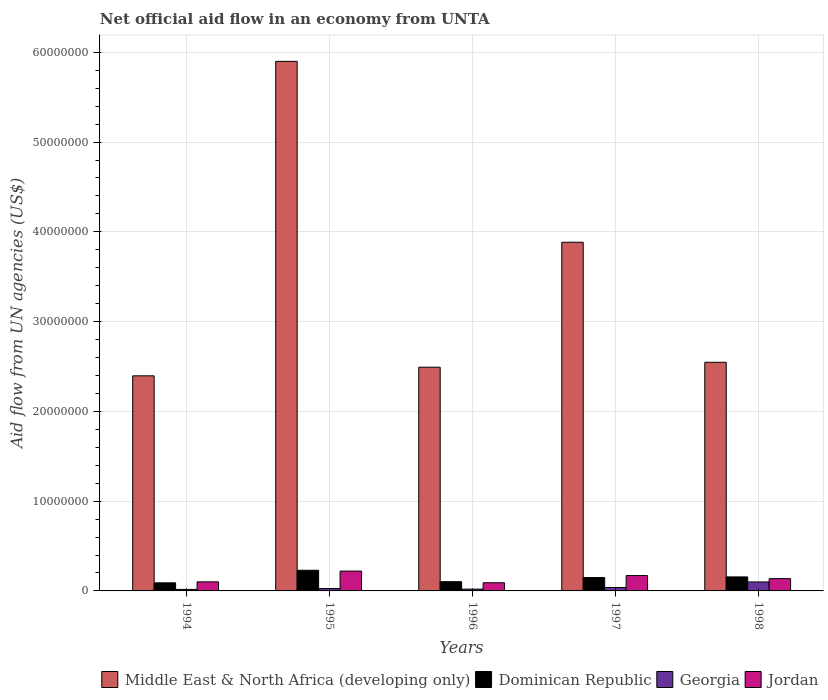How many different coloured bars are there?
Offer a very short reply. 4. How many groups of bars are there?
Your answer should be very brief. 5. Are the number of bars on each tick of the X-axis equal?
Offer a very short reply. Yes. How many bars are there on the 1st tick from the left?
Provide a succinct answer. 4. How many bars are there on the 3rd tick from the right?
Offer a terse response. 4. What is the label of the 3rd group of bars from the left?
Keep it short and to the point. 1996. In how many cases, is the number of bars for a given year not equal to the number of legend labels?
Give a very brief answer. 0. What is the net official aid flow in Dominican Republic in 1996?
Keep it short and to the point. 1.03e+06. Across all years, what is the maximum net official aid flow in Dominican Republic?
Offer a terse response. 2.30e+06. Across all years, what is the minimum net official aid flow in Jordan?
Your answer should be very brief. 9.10e+05. In which year was the net official aid flow in Jordan minimum?
Ensure brevity in your answer.  1996. What is the total net official aid flow in Dominican Republic in the graph?
Offer a terse response. 7.28e+06. What is the difference between the net official aid flow in Georgia in 1998 and the net official aid flow in Jordan in 1995?
Ensure brevity in your answer.  -1.21e+06. What is the average net official aid flow in Dominican Republic per year?
Offer a very short reply. 1.46e+06. In the year 1994, what is the difference between the net official aid flow in Jordan and net official aid flow in Georgia?
Ensure brevity in your answer.  8.40e+05. In how many years, is the net official aid flow in Middle East & North Africa (developing only) greater than 56000000 US$?
Keep it short and to the point. 1. What is the ratio of the net official aid flow in Jordan in 1995 to that in 1997?
Provide a succinct answer. 1.29. Is the net official aid flow in Dominican Republic in 1995 less than that in 1998?
Make the answer very short. No. What is the difference between the highest and the second highest net official aid flow in Dominican Republic?
Offer a terse response. 7.40e+05. What is the difference between the highest and the lowest net official aid flow in Middle East & North Africa (developing only)?
Make the answer very short. 3.50e+07. Is the sum of the net official aid flow in Dominican Republic in 1996 and 1997 greater than the maximum net official aid flow in Middle East & North Africa (developing only) across all years?
Your response must be concise. No. Is it the case that in every year, the sum of the net official aid flow in Jordan and net official aid flow in Middle East & North Africa (developing only) is greater than the sum of net official aid flow in Dominican Republic and net official aid flow in Georgia?
Make the answer very short. Yes. What does the 3rd bar from the left in 1994 represents?
Your answer should be compact. Georgia. What does the 4th bar from the right in 1996 represents?
Make the answer very short. Middle East & North Africa (developing only). Is it the case that in every year, the sum of the net official aid flow in Georgia and net official aid flow in Jordan is greater than the net official aid flow in Dominican Republic?
Give a very brief answer. Yes. Are all the bars in the graph horizontal?
Your answer should be compact. No. What is the difference between two consecutive major ticks on the Y-axis?
Provide a succinct answer. 1.00e+07. How many legend labels are there?
Your answer should be very brief. 4. What is the title of the graph?
Provide a succinct answer. Net official aid flow in an economy from UNTA. What is the label or title of the Y-axis?
Offer a terse response. Aid flow from UN agencies (US$). What is the Aid flow from UN agencies (US$) in Middle East & North Africa (developing only) in 1994?
Provide a succinct answer. 2.40e+07. What is the Aid flow from UN agencies (US$) of Dominican Republic in 1994?
Ensure brevity in your answer.  9.00e+05. What is the Aid flow from UN agencies (US$) in Jordan in 1994?
Your answer should be very brief. 1.01e+06. What is the Aid flow from UN agencies (US$) in Middle East & North Africa (developing only) in 1995?
Provide a succinct answer. 5.90e+07. What is the Aid flow from UN agencies (US$) of Dominican Republic in 1995?
Your answer should be compact. 2.30e+06. What is the Aid flow from UN agencies (US$) of Jordan in 1995?
Your response must be concise. 2.21e+06. What is the Aid flow from UN agencies (US$) of Middle East & North Africa (developing only) in 1996?
Make the answer very short. 2.49e+07. What is the Aid flow from UN agencies (US$) of Dominican Republic in 1996?
Keep it short and to the point. 1.03e+06. What is the Aid flow from UN agencies (US$) of Georgia in 1996?
Provide a succinct answer. 2.00e+05. What is the Aid flow from UN agencies (US$) of Jordan in 1996?
Your answer should be compact. 9.10e+05. What is the Aid flow from UN agencies (US$) of Middle East & North Africa (developing only) in 1997?
Make the answer very short. 3.88e+07. What is the Aid flow from UN agencies (US$) in Dominican Republic in 1997?
Your response must be concise. 1.49e+06. What is the Aid flow from UN agencies (US$) in Georgia in 1997?
Provide a short and direct response. 3.80e+05. What is the Aid flow from UN agencies (US$) in Jordan in 1997?
Give a very brief answer. 1.71e+06. What is the Aid flow from UN agencies (US$) of Middle East & North Africa (developing only) in 1998?
Provide a succinct answer. 2.55e+07. What is the Aid flow from UN agencies (US$) in Dominican Republic in 1998?
Offer a terse response. 1.56e+06. What is the Aid flow from UN agencies (US$) in Jordan in 1998?
Your response must be concise. 1.37e+06. Across all years, what is the maximum Aid flow from UN agencies (US$) in Middle East & North Africa (developing only)?
Your response must be concise. 5.90e+07. Across all years, what is the maximum Aid flow from UN agencies (US$) of Dominican Republic?
Provide a short and direct response. 2.30e+06. Across all years, what is the maximum Aid flow from UN agencies (US$) of Jordan?
Your answer should be very brief. 2.21e+06. Across all years, what is the minimum Aid flow from UN agencies (US$) in Middle East & North Africa (developing only)?
Make the answer very short. 2.40e+07. Across all years, what is the minimum Aid flow from UN agencies (US$) in Dominican Republic?
Offer a terse response. 9.00e+05. Across all years, what is the minimum Aid flow from UN agencies (US$) of Georgia?
Your response must be concise. 1.70e+05. Across all years, what is the minimum Aid flow from UN agencies (US$) in Jordan?
Provide a short and direct response. 9.10e+05. What is the total Aid flow from UN agencies (US$) of Middle East & North Africa (developing only) in the graph?
Keep it short and to the point. 1.72e+08. What is the total Aid flow from UN agencies (US$) in Dominican Republic in the graph?
Your response must be concise. 7.28e+06. What is the total Aid flow from UN agencies (US$) of Georgia in the graph?
Provide a short and direct response. 2.02e+06. What is the total Aid flow from UN agencies (US$) in Jordan in the graph?
Keep it short and to the point. 7.21e+06. What is the difference between the Aid flow from UN agencies (US$) of Middle East & North Africa (developing only) in 1994 and that in 1995?
Make the answer very short. -3.50e+07. What is the difference between the Aid flow from UN agencies (US$) of Dominican Republic in 1994 and that in 1995?
Your response must be concise. -1.40e+06. What is the difference between the Aid flow from UN agencies (US$) of Jordan in 1994 and that in 1995?
Offer a very short reply. -1.20e+06. What is the difference between the Aid flow from UN agencies (US$) in Middle East & North Africa (developing only) in 1994 and that in 1996?
Offer a very short reply. -9.60e+05. What is the difference between the Aid flow from UN agencies (US$) in Dominican Republic in 1994 and that in 1996?
Keep it short and to the point. -1.30e+05. What is the difference between the Aid flow from UN agencies (US$) of Georgia in 1994 and that in 1996?
Make the answer very short. -3.00e+04. What is the difference between the Aid flow from UN agencies (US$) of Jordan in 1994 and that in 1996?
Your response must be concise. 1.00e+05. What is the difference between the Aid flow from UN agencies (US$) of Middle East & North Africa (developing only) in 1994 and that in 1997?
Your answer should be compact. -1.49e+07. What is the difference between the Aid flow from UN agencies (US$) in Dominican Republic in 1994 and that in 1997?
Your response must be concise. -5.90e+05. What is the difference between the Aid flow from UN agencies (US$) of Georgia in 1994 and that in 1997?
Your answer should be compact. -2.10e+05. What is the difference between the Aid flow from UN agencies (US$) in Jordan in 1994 and that in 1997?
Give a very brief answer. -7.00e+05. What is the difference between the Aid flow from UN agencies (US$) in Middle East & North Africa (developing only) in 1994 and that in 1998?
Provide a succinct answer. -1.51e+06. What is the difference between the Aid flow from UN agencies (US$) in Dominican Republic in 1994 and that in 1998?
Give a very brief answer. -6.60e+05. What is the difference between the Aid flow from UN agencies (US$) of Georgia in 1994 and that in 1998?
Ensure brevity in your answer.  -8.30e+05. What is the difference between the Aid flow from UN agencies (US$) in Jordan in 1994 and that in 1998?
Give a very brief answer. -3.60e+05. What is the difference between the Aid flow from UN agencies (US$) of Middle East & North Africa (developing only) in 1995 and that in 1996?
Make the answer very short. 3.41e+07. What is the difference between the Aid flow from UN agencies (US$) in Dominican Republic in 1995 and that in 1996?
Provide a short and direct response. 1.27e+06. What is the difference between the Aid flow from UN agencies (US$) of Georgia in 1995 and that in 1996?
Your response must be concise. 7.00e+04. What is the difference between the Aid flow from UN agencies (US$) of Jordan in 1995 and that in 1996?
Offer a very short reply. 1.30e+06. What is the difference between the Aid flow from UN agencies (US$) in Middle East & North Africa (developing only) in 1995 and that in 1997?
Give a very brief answer. 2.02e+07. What is the difference between the Aid flow from UN agencies (US$) in Dominican Republic in 1995 and that in 1997?
Provide a short and direct response. 8.10e+05. What is the difference between the Aid flow from UN agencies (US$) of Middle East & North Africa (developing only) in 1995 and that in 1998?
Your response must be concise. 3.35e+07. What is the difference between the Aid flow from UN agencies (US$) in Dominican Republic in 1995 and that in 1998?
Provide a short and direct response. 7.40e+05. What is the difference between the Aid flow from UN agencies (US$) in Georgia in 1995 and that in 1998?
Provide a succinct answer. -7.30e+05. What is the difference between the Aid flow from UN agencies (US$) of Jordan in 1995 and that in 1998?
Provide a short and direct response. 8.40e+05. What is the difference between the Aid flow from UN agencies (US$) of Middle East & North Africa (developing only) in 1996 and that in 1997?
Make the answer very short. -1.39e+07. What is the difference between the Aid flow from UN agencies (US$) of Dominican Republic in 1996 and that in 1997?
Your answer should be compact. -4.60e+05. What is the difference between the Aid flow from UN agencies (US$) in Georgia in 1996 and that in 1997?
Your response must be concise. -1.80e+05. What is the difference between the Aid flow from UN agencies (US$) in Jordan in 1996 and that in 1997?
Make the answer very short. -8.00e+05. What is the difference between the Aid flow from UN agencies (US$) of Middle East & North Africa (developing only) in 1996 and that in 1998?
Offer a terse response. -5.50e+05. What is the difference between the Aid flow from UN agencies (US$) of Dominican Republic in 1996 and that in 1998?
Ensure brevity in your answer.  -5.30e+05. What is the difference between the Aid flow from UN agencies (US$) in Georgia in 1996 and that in 1998?
Offer a terse response. -8.00e+05. What is the difference between the Aid flow from UN agencies (US$) of Jordan in 1996 and that in 1998?
Offer a terse response. -4.60e+05. What is the difference between the Aid flow from UN agencies (US$) of Middle East & North Africa (developing only) in 1997 and that in 1998?
Keep it short and to the point. 1.34e+07. What is the difference between the Aid flow from UN agencies (US$) of Georgia in 1997 and that in 1998?
Your answer should be very brief. -6.20e+05. What is the difference between the Aid flow from UN agencies (US$) in Middle East & North Africa (developing only) in 1994 and the Aid flow from UN agencies (US$) in Dominican Republic in 1995?
Give a very brief answer. 2.17e+07. What is the difference between the Aid flow from UN agencies (US$) in Middle East & North Africa (developing only) in 1994 and the Aid flow from UN agencies (US$) in Georgia in 1995?
Ensure brevity in your answer.  2.37e+07. What is the difference between the Aid flow from UN agencies (US$) in Middle East & North Africa (developing only) in 1994 and the Aid flow from UN agencies (US$) in Jordan in 1995?
Provide a succinct answer. 2.18e+07. What is the difference between the Aid flow from UN agencies (US$) in Dominican Republic in 1994 and the Aid flow from UN agencies (US$) in Georgia in 1995?
Keep it short and to the point. 6.30e+05. What is the difference between the Aid flow from UN agencies (US$) in Dominican Republic in 1994 and the Aid flow from UN agencies (US$) in Jordan in 1995?
Your answer should be compact. -1.31e+06. What is the difference between the Aid flow from UN agencies (US$) in Georgia in 1994 and the Aid flow from UN agencies (US$) in Jordan in 1995?
Your answer should be compact. -2.04e+06. What is the difference between the Aid flow from UN agencies (US$) in Middle East & North Africa (developing only) in 1994 and the Aid flow from UN agencies (US$) in Dominican Republic in 1996?
Your answer should be very brief. 2.29e+07. What is the difference between the Aid flow from UN agencies (US$) of Middle East & North Africa (developing only) in 1994 and the Aid flow from UN agencies (US$) of Georgia in 1996?
Ensure brevity in your answer.  2.38e+07. What is the difference between the Aid flow from UN agencies (US$) of Middle East & North Africa (developing only) in 1994 and the Aid flow from UN agencies (US$) of Jordan in 1996?
Provide a succinct answer. 2.30e+07. What is the difference between the Aid flow from UN agencies (US$) of Dominican Republic in 1994 and the Aid flow from UN agencies (US$) of Georgia in 1996?
Offer a terse response. 7.00e+05. What is the difference between the Aid flow from UN agencies (US$) of Georgia in 1994 and the Aid flow from UN agencies (US$) of Jordan in 1996?
Ensure brevity in your answer.  -7.40e+05. What is the difference between the Aid flow from UN agencies (US$) in Middle East & North Africa (developing only) in 1994 and the Aid flow from UN agencies (US$) in Dominican Republic in 1997?
Your answer should be compact. 2.25e+07. What is the difference between the Aid flow from UN agencies (US$) in Middle East & North Africa (developing only) in 1994 and the Aid flow from UN agencies (US$) in Georgia in 1997?
Offer a very short reply. 2.36e+07. What is the difference between the Aid flow from UN agencies (US$) in Middle East & North Africa (developing only) in 1994 and the Aid flow from UN agencies (US$) in Jordan in 1997?
Offer a terse response. 2.22e+07. What is the difference between the Aid flow from UN agencies (US$) of Dominican Republic in 1994 and the Aid flow from UN agencies (US$) of Georgia in 1997?
Your answer should be very brief. 5.20e+05. What is the difference between the Aid flow from UN agencies (US$) of Dominican Republic in 1994 and the Aid flow from UN agencies (US$) of Jordan in 1997?
Provide a succinct answer. -8.10e+05. What is the difference between the Aid flow from UN agencies (US$) in Georgia in 1994 and the Aid flow from UN agencies (US$) in Jordan in 1997?
Offer a very short reply. -1.54e+06. What is the difference between the Aid flow from UN agencies (US$) in Middle East & North Africa (developing only) in 1994 and the Aid flow from UN agencies (US$) in Dominican Republic in 1998?
Give a very brief answer. 2.24e+07. What is the difference between the Aid flow from UN agencies (US$) in Middle East & North Africa (developing only) in 1994 and the Aid flow from UN agencies (US$) in Georgia in 1998?
Your answer should be compact. 2.30e+07. What is the difference between the Aid flow from UN agencies (US$) in Middle East & North Africa (developing only) in 1994 and the Aid flow from UN agencies (US$) in Jordan in 1998?
Keep it short and to the point. 2.26e+07. What is the difference between the Aid flow from UN agencies (US$) in Dominican Republic in 1994 and the Aid flow from UN agencies (US$) in Georgia in 1998?
Give a very brief answer. -1.00e+05. What is the difference between the Aid flow from UN agencies (US$) in Dominican Republic in 1994 and the Aid flow from UN agencies (US$) in Jordan in 1998?
Your answer should be very brief. -4.70e+05. What is the difference between the Aid flow from UN agencies (US$) of Georgia in 1994 and the Aid flow from UN agencies (US$) of Jordan in 1998?
Your response must be concise. -1.20e+06. What is the difference between the Aid flow from UN agencies (US$) in Middle East & North Africa (developing only) in 1995 and the Aid flow from UN agencies (US$) in Dominican Republic in 1996?
Offer a very short reply. 5.80e+07. What is the difference between the Aid flow from UN agencies (US$) in Middle East & North Africa (developing only) in 1995 and the Aid flow from UN agencies (US$) in Georgia in 1996?
Give a very brief answer. 5.88e+07. What is the difference between the Aid flow from UN agencies (US$) in Middle East & North Africa (developing only) in 1995 and the Aid flow from UN agencies (US$) in Jordan in 1996?
Offer a very short reply. 5.81e+07. What is the difference between the Aid flow from UN agencies (US$) in Dominican Republic in 1995 and the Aid flow from UN agencies (US$) in Georgia in 1996?
Give a very brief answer. 2.10e+06. What is the difference between the Aid flow from UN agencies (US$) of Dominican Republic in 1995 and the Aid flow from UN agencies (US$) of Jordan in 1996?
Your answer should be very brief. 1.39e+06. What is the difference between the Aid flow from UN agencies (US$) in Georgia in 1995 and the Aid flow from UN agencies (US$) in Jordan in 1996?
Make the answer very short. -6.40e+05. What is the difference between the Aid flow from UN agencies (US$) in Middle East & North Africa (developing only) in 1995 and the Aid flow from UN agencies (US$) in Dominican Republic in 1997?
Offer a very short reply. 5.75e+07. What is the difference between the Aid flow from UN agencies (US$) of Middle East & North Africa (developing only) in 1995 and the Aid flow from UN agencies (US$) of Georgia in 1997?
Your response must be concise. 5.86e+07. What is the difference between the Aid flow from UN agencies (US$) in Middle East & North Africa (developing only) in 1995 and the Aid flow from UN agencies (US$) in Jordan in 1997?
Ensure brevity in your answer.  5.73e+07. What is the difference between the Aid flow from UN agencies (US$) of Dominican Republic in 1995 and the Aid flow from UN agencies (US$) of Georgia in 1997?
Ensure brevity in your answer.  1.92e+06. What is the difference between the Aid flow from UN agencies (US$) of Dominican Republic in 1995 and the Aid flow from UN agencies (US$) of Jordan in 1997?
Give a very brief answer. 5.90e+05. What is the difference between the Aid flow from UN agencies (US$) in Georgia in 1995 and the Aid flow from UN agencies (US$) in Jordan in 1997?
Your response must be concise. -1.44e+06. What is the difference between the Aid flow from UN agencies (US$) in Middle East & North Africa (developing only) in 1995 and the Aid flow from UN agencies (US$) in Dominican Republic in 1998?
Your answer should be compact. 5.74e+07. What is the difference between the Aid flow from UN agencies (US$) in Middle East & North Africa (developing only) in 1995 and the Aid flow from UN agencies (US$) in Georgia in 1998?
Provide a short and direct response. 5.80e+07. What is the difference between the Aid flow from UN agencies (US$) of Middle East & North Africa (developing only) in 1995 and the Aid flow from UN agencies (US$) of Jordan in 1998?
Ensure brevity in your answer.  5.76e+07. What is the difference between the Aid flow from UN agencies (US$) of Dominican Republic in 1995 and the Aid flow from UN agencies (US$) of Georgia in 1998?
Your answer should be compact. 1.30e+06. What is the difference between the Aid flow from UN agencies (US$) of Dominican Republic in 1995 and the Aid flow from UN agencies (US$) of Jordan in 1998?
Your answer should be compact. 9.30e+05. What is the difference between the Aid flow from UN agencies (US$) of Georgia in 1995 and the Aid flow from UN agencies (US$) of Jordan in 1998?
Provide a short and direct response. -1.10e+06. What is the difference between the Aid flow from UN agencies (US$) of Middle East & North Africa (developing only) in 1996 and the Aid flow from UN agencies (US$) of Dominican Republic in 1997?
Provide a succinct answer. 2.34e+07. What is the difference between the Aid flow from UN agencies (US$) of Middle East & North Africa (developing only) in 1996 and the Aid flow from UN agencies (US$) of Georgia in 1997?
Give a very brief answer. 2.45e+07. What is the difference between the Aid flow from UN agencies (US$) in Middle East & North Africa (developing only) in 1996 and the Aid flow from UN agencies (US$) in Jordan in 1997?
Your response must be concise. 2.32e+07. What is the difference between the Aid flow from UN agencies (US$) in Dominican Republic in 1996 and the Aid flow from UN agencies (US$) in Georgia in 1997?
Offer a terse response. 6.50e+05. What is the difference between the Aid flow from UN agencies (US$) of Dominican Republic in 1996 and the Aid flow from UN agencies (US$) of Jordan in 1997?
Provide a short and direct response. -6.80e+05. What is the difference between the Aid flow from UN agencies (US$) of Georgia in 1996 and the Aid flow from UN agencies (US$) of Jordan in 1997?
Ensure brevity in your answer.  -1.51e+06. What is the difference between the Aid flow from UN agencies (US$) of Middle East & North Africa (developing only) in 1996 and the Aid flow from UN agencies (US$) of Dominican Republic in 1998?
Make the answer very short. 2.34e+07. What is the difference between the Aid flow from UN agencies (US$) in Middle East & North Africa (developing only) in 1996 and the Aid flow from UN agencies (US$) in Georgia in 1998?
Your answer should be compact. 2.39e+07. What is the difference between the Aid flow from UN agencies (US$) in Middle East & North Africa (developing only) in 1996 and the Aid flow from UN agencies (US$) in Jordan in 1998?
Ensure brevity in your answer.  2.36e+07. What is the difference between the Aid flow from UN agencies (US$) in Dominican Republic in 1996 and the Aid flow from UN agencies (US$) in Georgia in 1998?
Ensure brevity in your answer.  3.00e+04. What is the difference between the Aid flow from UN agencies (US$) of Dominican Republic in 1996 and the Aid flow from UN agencies (US$) of Jordan in 1998?
Your answer should be compact. -3.40e+05. What is the difference between the Aid flow from UN agencies (US$) in Georgia in 1996 and the Aid flow from UN agencies (US$) in Jordan in 1998?
Your answer should be very brief. -1.17e+06. What is the difference between the Aid flow from UN agencies (US$) in Middle East & North Africa (developing only) in 1997 and the Aid flow from UN agencies (US$) in Dominican Republic in 1998?
Offer a very short reply. 3.73e+07. What is the difference between the Aid flow from UN agencies (US$) in Middle East & North Africa (developing only) in 1997 and the Aid flow from UN agencies (US$) in Georgia in 1998?
Your answer should be compact. 3.78e+07. What is the difference between the Aid flow from UN agencies (US$) in Middle East & North Africa (developing only) in 1997 and the Aid flow from UN agencies (US$) in Jordan in 1998?
Make the answer very short. 3.75e+07. What is the difference between the Aid flow from UN agencies (US$) of Dominican Republic in 1997 and the Aid flow from UN agencies (US$) of Georgia in 1998?
Your answer should be very brief. 4.90e+05. What is the difference between the Aid flow from UN agencies (US$) in Georgia in 1997 and the Aid flow from UN agencies (US$) in Jordan in 1998?
Your answer should be compact. -9.90e+05. What is the average Aid flow from UN agencies (US$) of Middle East & North Africa (developing only) per year?
Your answer should be compact. 3.44e+07. What is the average Aid flow from UN agencies (US$) of Dominican Republic per year?
Your response must be concise. 1.46e+06. What is the average Aid flow from UN agencies (US$) of Georgia per year?
Provide a short and direct response. 4.04e+05. What is the average Aid flow from UN agencies (US$) of Jordan per year?
Give a very brief answer. 1.44e+06. In the year 1994, what is the difference between the Aid flow from UN agencies (US$) in Middle East & North Africa (developing only) and Aid flow from UN agencies (US$) in Dominican Republic?
Your answer should be compact. 2.31e+07. In the year 1994, what is the difference between the Aid flow from UN agencies (US$) of Middle East & North Africa (developing only) and Aid flow from UN agencies (US$) of Georgia?
Provide a short and direct response. 2.38e+07. In the year 1994, what is the difference between the Aid flow from UN agencies (US$) in Middle East & North Africa (developing only) and Aid flow from UN agencies (US$) in Jordan?
Offer a terse response. 2.30e+07. In the year 1994, what is the difference between the Aid flow from UN agencies (US$) of Dominican Republic and Aid flow from UN agencies (US$) of Georgia?
Provide a succinct answer. 7.30e+05. In the year 1994, what is the difference between the Aid flow from UN agencies (US$) in Dominican Republic and Aid flow from UN agencies (US$) in Jordan?
Provide a succinct answer. -1.10e+05. In the year 1994, what is the difference between the Aid flow from UN agencies (US$) in Georgia and Aid flow from UN agencies (US$) in Jordan?
Provide a short and direct response. -8.40e+05. In the year 1995, what is the difference between the Aid flow from UN agencies (US$) in Middle East & North Africa (developing only) and Aid flow from UN agencies (US$) in Dominican Republic?
Offer a very short reply. 5.67e+07. In the year 1995, what is the difference between the Aid flow from UN agencies (US$) in Middle East & North Africa (developing only) and Aid flow from UN agencies (US$) in Georgia?
Offer a terse response. 5.87e+07. In the year 1995, what is the difference between the Aid flow from UN agencies (US$) in Middle East & North Africa (developing only) and Aid flow from UN agencies (US$) in Jordan?
Make the answer very short. 5.68e+07. In the year 1995, what is the difference between the Aid flow from UN agencies (US$) of Dominican Republic and Aid flow from UN agencies (US$) of Georgia?
Provide a succinct answer. 2.03e+06. In the year 1995, what is the difference between the Aid flow from UN agencies (US$) in Georgia and Aid flow from UN agencies (US$) in Jordan?
Ensure brevity in your answer.  -1.94e+06. In the year 1996, what is the difference between the Aid flow from UN agencies (US$) in Middle East & North Africa (developing only) and Aid flow from UN agencies (US$) in Dominican Republic?
Your answer should be compact. 2.39e+07. In the year 1996, what is the difference between the Aid flow from UN agencies (US$) of Middle East & North Africa (developing only) and Aid flow from UN agencies (US$) of Georgia?
Your answer should be compact. 2.47e+07. In the year 1996, what is the difference between the Aid flow from UN agencies (US$) of Middle East & North Africa (developing only) and Aid flow from UN agencies (US$) of Jordan?
Make the answer very short. 2.40e+07. In the year 1996, what is the difference between the Aid flow from UN agencies (US$) in Dominican Republic and Aid flow from UN agencies (US$) in Georgia?
Ensure brevity in your answer.  8.30e+05. In the year 1996, what is the difference between the Aid flow from UN agencies (US$) of Georgia and Aid flow from UN agencies (US$) of Jordan?
Your answer should be compact. -7.10e+05. In the year 1997, what is the difference between the Aid flow from UN agencies (US$) in Middle East & North Africa (developing only) and Aid flow from UN agencies (US$) in Dominican Republic?
Provide a succinct answer. 3.74e+07. In the year 1997, what is the difference between the Aid flow from UN agencies (US$) in Middle East & North Africa (developing only) and Aid flow from UN agencies (US$) in Georgia?
Ensure brevity in your answer.  3.85e+07. In the year 1997, what is the difference between the Aid flow from UN agencies (US$) in Middle East & North Africa (developing only) and Aid flow from UN agencies (US$) in Jordan?
Provide a succinct answer. 3.71e+07. In the year 1997, what is the difference between the Aid flow from UN agencies (US$) of Dominican Republic and Aid flow from UN agencies (US$) of Georgia?
Your answer should be very brief. 1.11e+06. In the year 1997, what is the difference between the Aid flow from UN agencies (US$) in Georgia and Aid flow from UN agencies (US$) in Jordan?
Your response must be concise. -1.33e+06. In the year 1998, what is the difference between the Aid flow from UN agencies (US$) in Middle East & North Africa (developing only) and Aid flow from UN agencies (US$) in Dominican Republic?
Give a very brief answer. 2.39e+07. In the year 1998, what is the difference between the Aid flow from UN agencies (US$) in Middle East & North Africa (developing only) and Aid flow from UN agencies (US$) in Georgia?
Your response must be concise. 2.45e+07. In the year 1998, what is the difference between the Aid flow from UN agencies (US$) in Middle East & North Africa (developing only) and Aid flow from UN agencies (US$) in Jordan?
Provide a succinct answer. 2.41e+07. In the year 1998, what is the difference between the Aid flow from UN agencies (US$) of Dominican Republic and Aid flow from UN agencies (US$) of Georgia?
Ensure brevity in your answer.  5.60e+05. In the year 1998, what is the difference between the Aid flow from UN agencies (US$) in Georgia and Aid flow from UN agencies (US$) in Jordan?
Provide a short and direct response. -3.70e+05. What is the ratio of the Aid flow from UN agencies (US$) of Middle East & North Africa (developing only) in 1994 to that in 1995?
Give a very brief answer. 0.41. What is the ratio of the Aid flow from UN agencies (US$) of Dominican Republic in 1994 to that in 1995?
Keep it short and to the point. 0.39. What is the ratio of the Aid flow from UN agencies (US$) in Georgia in 1994 to that in 1995?
Ensure brevity in your answer.  0.63. What is the ratio of the Aid flow from UN agencies (US$) of Jordan in 1994 to that in 1995?
Keep it short and to the point. 0.46. What is the ratio of the Aid flow from UN agencies (US$) of Middle East & North Africa (developing only) in 1994 to that in 1996?
Keep it short and to the point. 0.96. What is the ratio of the Aid flow from UN agencies (US$) in Dominican Republic in 1994 to that in 1996?
Keep it short and to the point. 0.87. What is the ratio of the Aid flow from UN agencies (US$) of Jordan in 1994 to that in 1996?
Offer a very short reply. 1.11. What is the ratio of the Aid flow from UN agencies (US$) of Middle East & North Africa (developing only) in 1994 to that in 1997?
Offer a very short reply. 0.62. What is the ratio of the Aid flow from UN agencies (US$) of Dominican Republic in 1994 to that in 1997?
Your answer should be very brief. 0.6. What is the ratio of the Aid flow from UN agencies (US$) of Georgia in 1994 to that in 1997?
Give a very brief answer. 0.45. What is the ratio of the Aid flow from UN agencies (US$) of Jordan in 1994 to that in 1997?
Provide a succinct answer. 0.59. What is the ratio of the Aid flow from UN agencies (US$) in Middle East & North Africa (developing only) in 1994 to that in 1998?
Your answer should be very brief. 0.94. What is the ratio of the Aid flow from UN agencies (US$) of Dominican Republic in 1994 to that in 1998?
Your answer should be very brief. 0.58. What is the ratio of the Aid flow from UN agencies (US$) in Georgia in 1994 to that in 1998?
Your response must be concise. 0.17. What is the ratio of the Aid flow from UN agencies (US$) of Jordan in 1994 to that in 1998?
Your answer should be compact. 0.74. What is the ratio of the Aid flow from UN agencies (US$) in Middle East & North Africa (developing only) in 1995 to that in 1996?
Give a very brief answer. 2.37. What is the ratio of the Aid flow from UN agencies (US$) of Dominican Republic in 1995 to that in 1996?
Offer a terse response. 2.23. What is the ratio of the Aid flow from UN agencies (US$) of Georgia in 1995 to that in 1996?
Your answer should be very brief. 1.35. What is the ratio of the Aid flow from UN agencies (US$) in Jordan in 1995 to that in 1996?
Provide a short and direct response. 2.43. What is the ratio of the Aid flow from UN agencies (US$) in Middle East & North Africa (developing only) in 1995 to that in 1997?
Offer a very short reply. 1.52. What is the ratio of the Aid flow from UN agencies (US$) of Dominican Republic in 1995 to that in 1997?
Offer a very short reply. 1.54. What is the ratio of the Aid flow from UN agencies (US$) of Georgia in 1995 to that in 1997?
Provide a succinct answer. 0.71. What is the ratio of the Aid flow from UN agencies (US$) in Jordan in 1995 to that in 1997?
Offer a terse response. 1.29. What is the ratio of the Aid flow from UN agencies (US$) in Middle East & North Africa (developing only) in 1995 to that in 1998?
Give a very brief answer. 2.32. What is the ratio of the Aid flow from UN agencies (US$) in Dominican Republic in 1995 to that in 1998?
Your response must be concise. 1.47. What is the ratio of the Aid flow from UN agencies (US$) in Georgia in 1995 to that in 1998?
Offer a very short reply. 0.27. What is the ratio of the Aid flow from UN agencies (US$) of Jordan in 1995 to that in 1998?
Offer a very short reply. 1.61. What is the ratio of the Aid flow from UN agencies (US$) in Middle East & North Africa (developing only) in 1996 to that in 1997?
Provide a succinct answer. 0.64. What is the ratio of the Aid flow from UN agencies (US$) of Dominican Republic in 1996 to that in 1997?
Your response must be concise. 0.69. What is the ratio of the Aid flow from UN agencies (US$) in Georgia in 1996 to that in 1997?
Provide a succinct answer. 0.53. What is the ratio of the Aid flow from UN agencies (US$) of Jordan in 1996 to that in 1997?
Provide a succinct answer. 0.53. What is the ratio of the Aid flow from UN agencies (US$) of Middle East & North Africa (developing only) in 1996 to that in 1998?
Give a very brief answer. 0.98. What is the ratio of the Aid flow from UN agencies (US$) of Dominican Republic in 1996 to that in 1998?
Offer a very short reply. 0.66. What is the ratio of the Aid flow from UN agencies (US$) of Georgia in 1996 to that in 1998?
Your answer should be compact. 0.2. What is the ratio of the Aid flow from UN agencies (US$) of Jordan in 1996 to that in 1998?
Your response must be concise. 0.66. What is the ratio of the Aid flow from UN agencies (US$) in Middle East & North Africa (developing only) in 1997 to that in 1998?
Keep it short and to the point. 1.52. What is the ratio of the Aid flow from UN agencies (US$) of Dominican Republic in 1997 to that in 1998?
Give a very brief answer. 0.96. What is the ratio of the Aid flow from UN agencies (US$) in Georgia in 1997 to that in 1998?
Make the answer very short. 0.38. What is the ratio of the Aid flow from UN agencies (US$) of Jordan in 1997 to that in 1998?
Give a very brief answer. 1.25. What is the difference between the highest and the second highest Aid flow from UN agencies (US$) of Middle East & North Africa (developing only)?
Make the answer very short. 2.02e+07. What is the difference between the highest and the second highest Aid flow from UN agencies (US$) of Dominican Republic?
Give a very brief answer. 7.40e+05. What is the difference between the highest and the second highest Aid flow from UN agencies (US$) in Georgia?
Make the answer very short. 6.20e+05. What is the difference between the highest and the lowest Aid flow from UN agencies (US$) of Middle East & North Africa (developing only)?
Your answer should be very brief. 3.50e+07. What is the difference between the highest and the lowest Aid flow from UN agencies (US$) in Dominican Republic?
Provide a succinct answer. 1.40e+06. What is the difference between the highest and the lowest Aid flow from UN agencies (US$) of Georgia?
Your response must be concise. 8.30e+05. What is the difference between the highest and the lowest Aid flow from UN agencies (US$) of Jordan?
Your answer should be compact. 1.30e+06. 